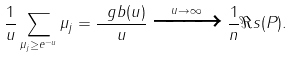<formula> <loc_0><loc_0><loc_500><loc_500>\frac { 1 } { u } \sum _ { \mu _ { j } \geq e ^ { - u } } \mu _ { j } = \frac { \ g b ( u ) } { u } \xrightarrow { u \to \infty } \frac { 1 } { n } \Re s ( P ) .</formula> 